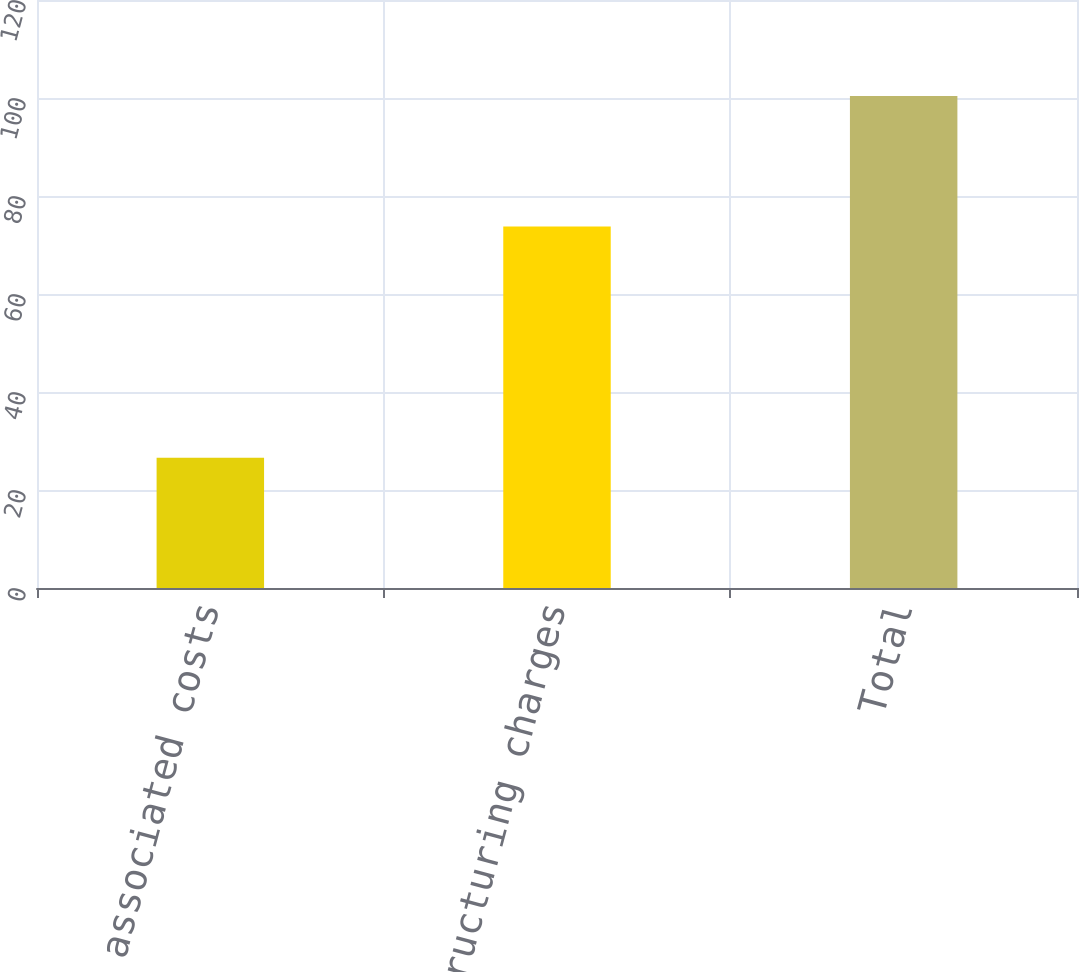<chart> <loc_0><loc_0><loc_500><loc_500><bar_chart><fcel>Other associated costs<fcel>Restructuring charges<fcel>Total<nl><fcel>26.6<fcel>73.8<fcel>100.4<nl></chart> 